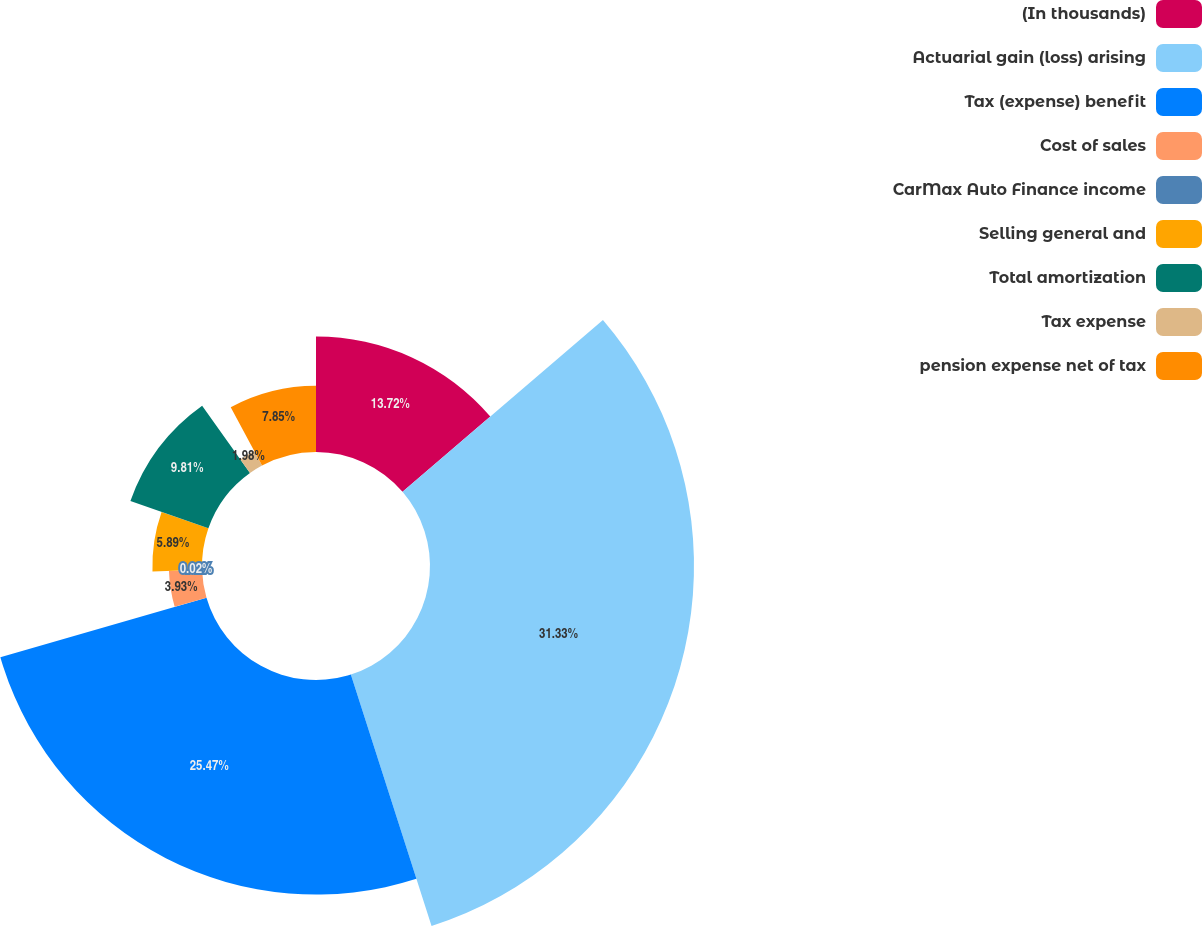Convert chart to OTSL. <chart><loc_0><loc_0><loc_500><loc_500><pie_chart><fcel>(In thousands)<fcel>Actuarial gain (loss) arising<fcel>Tax (expense) benefit<fcel>Cost of sales<fcel>CarMax Auto Finance income<fcel>Selling general and<fcel>Total amortization<fcel>Tax expense<fcel>pension expense net of tax<nl><fcel>13.72%<fcel>31.34%<fcel>25.47%<fcel>3.93%<fcel>0.02%<fcel>5.89%<fcel>9.81%<fcel>1.98%<fcel>7.85%<nl></chart> 